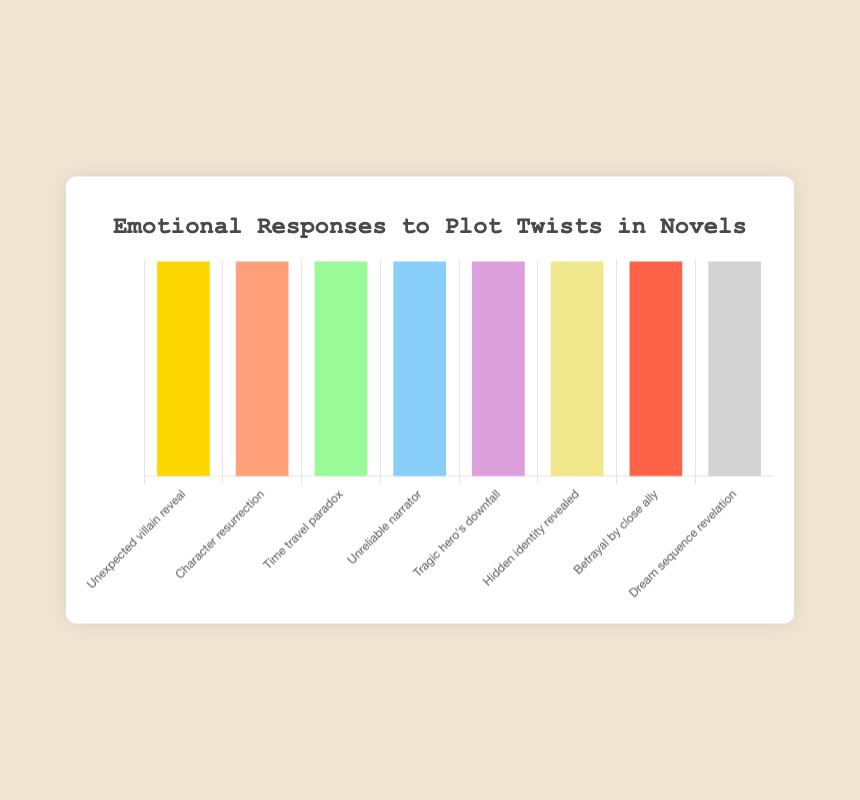Which plot twist represents the emotional response of 😲? To determine the emotional response, look for the 😲 emoji in the figure. It corresponds to the "Unexpected villain reveal" plot twist.
Answer: Unexpected villain reveal How do readers react emotionally to a "Character resurrection"? Identify the plot twist labeled as "Character resurrection" and check the associated emoji. It is 🥹.
Answer: 🥹 What is the emotional response depicted by 😠 in the chart? Locate the 😠 emoji and identify the plot twist it represents. This emoji is linked to "Betrayal by close ally".
Answer: Betrayal by close ally Between "Time travel paradox" and "Hidden identity revealed", which has a more astonished response? Compare the emojis for both plot twists: "Time travel paradox" (🤯) and "Hidden identity revealed" (😮). The 🤯 emoji indicates a more astonished response.
Answer: Time travel paradox Which plot twist causes a more confused reaction, "Time travel paradox" or "Unreliable narrator"? Compare the emojis for both: "Time travel paradox" (🤯) and "Unreliable narrator" (🤨). The 🤨 emoji suggests more confusion.
Answer: Unreliable narrator List all plot twists that evoke a sad response in the chart. Identify emojis that signify sadness: 😭 for "Tragic hero's downfall" and 😠 for "Betrayal by close ally".
Answer: Tragic hero's downfall, Betrayal by close ally What is the average emotional reaction to "Dream sequence revelation" and "Character resurrection"? Look for the emojis related to these plot twists: 😑 for "Dream sequence revelation" and 🥹 for "Character resurrection". Their average reaction can't be numerically calculated but involves both indifference (😑) and emotional (🥹).
Answer: Indifferent and emotional What does the 😮 emoji correspond to in the figure? Find the 😮 emoji and check the plot twist it represents. It corresponds to "Hidden identity revealed".
Answer: Hidden identity revealed 